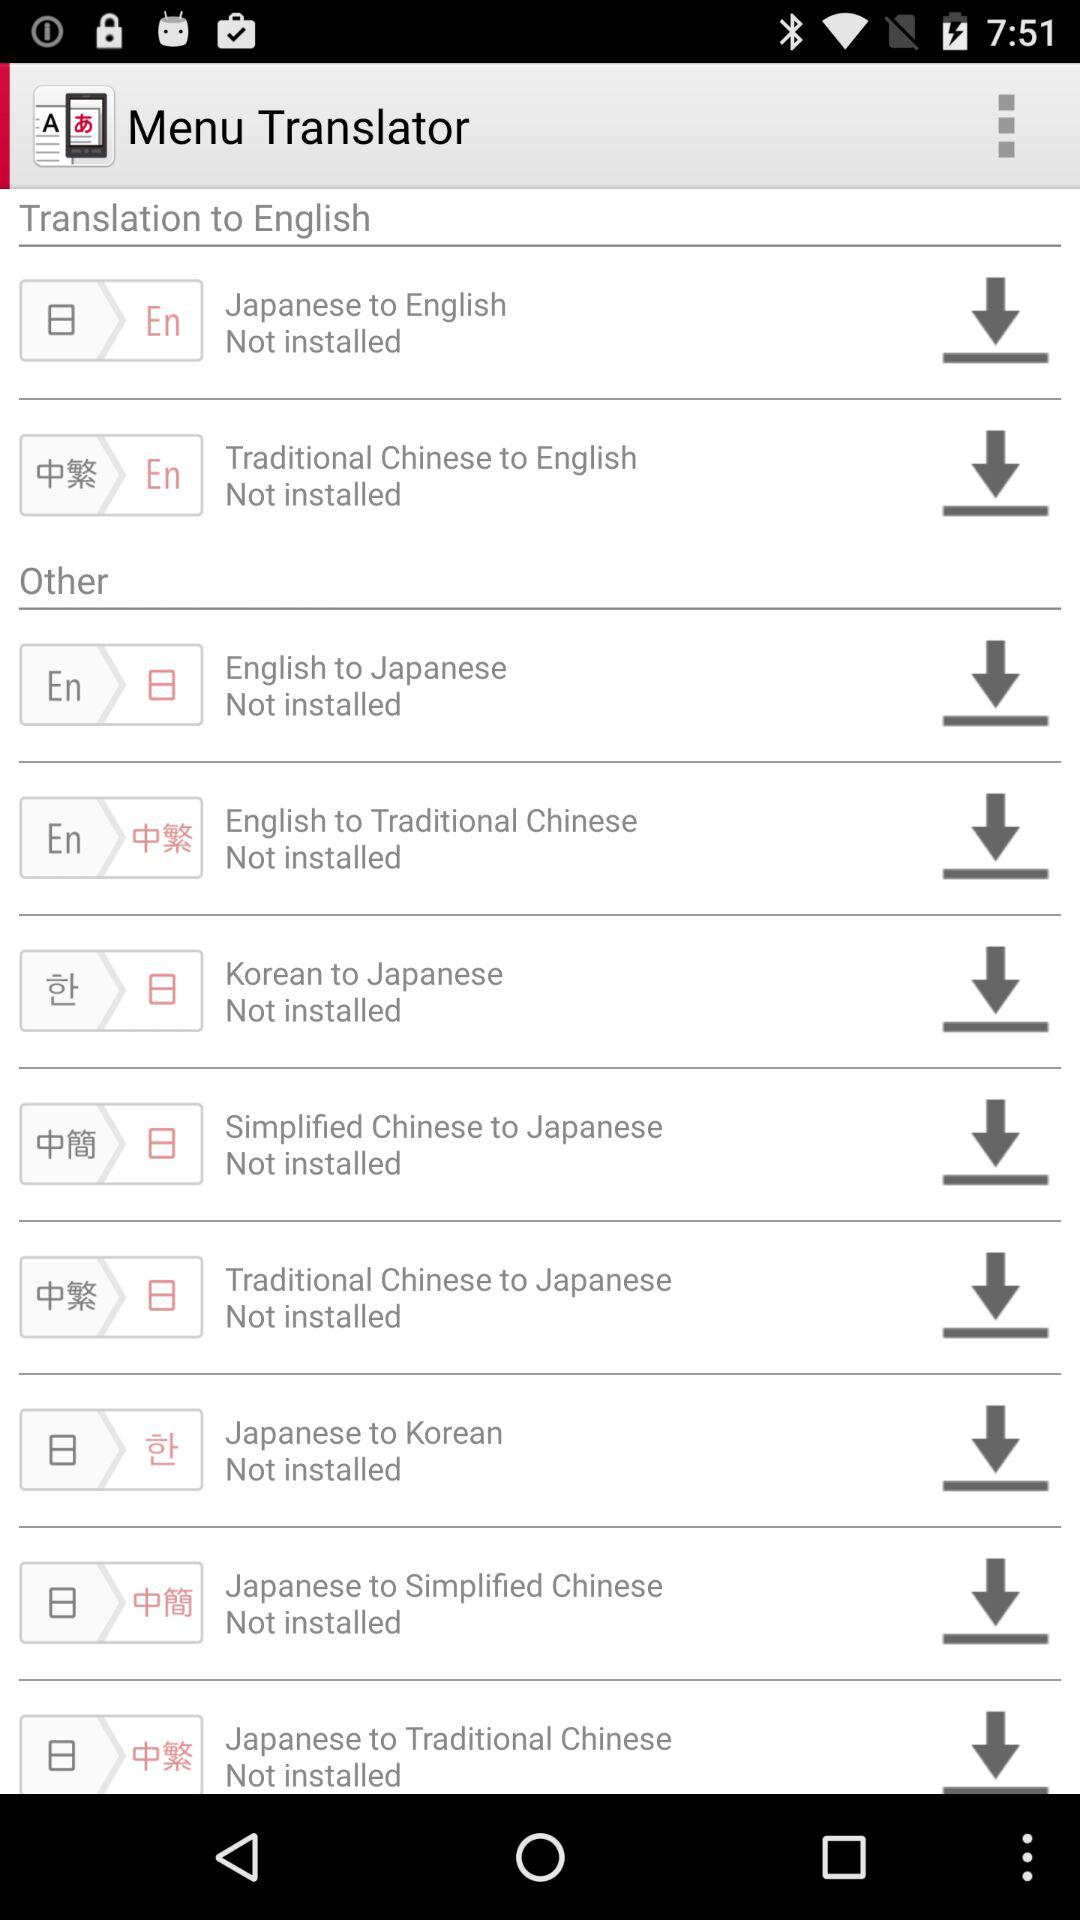What type of translator has been installed?
When the provided information is insufficient, respond with <no answer>. <no answer> 